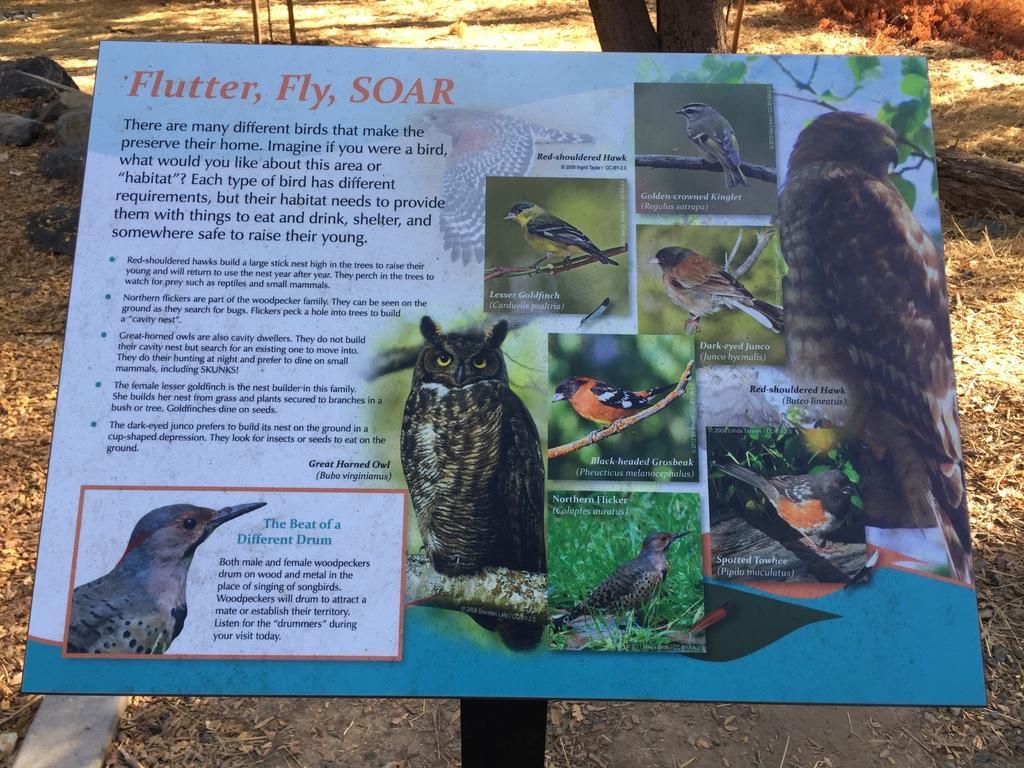How would you summarize this image in a sentence or two? This picture is clicked outside. In the center we can see the text and pictures of birds on the poster. In the background we can see the grass, rocks and some other items. 